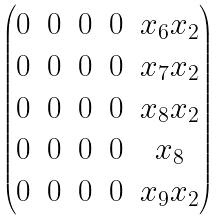Convert formula to latex. <formula><loc_0><loc_0><loc_500><loc_500>\begin{pmatrix} 0 & 0 & 0 & 0 & x _ { 6 } x _ { 2 } \\ 0 & 0 & 0 & 0 & x _ { 7 } x _ { 2 } \\ 0 & 0 & 0 & 0 & x _ { 8 } x _ { 2 } \\ 0 & 0 & 0 & 0 & x _ { 8 } \\ 0 & 0 & 0 & 0 & x _ { 9 } x _ { 2 } \end{pmatrix}</formula> 